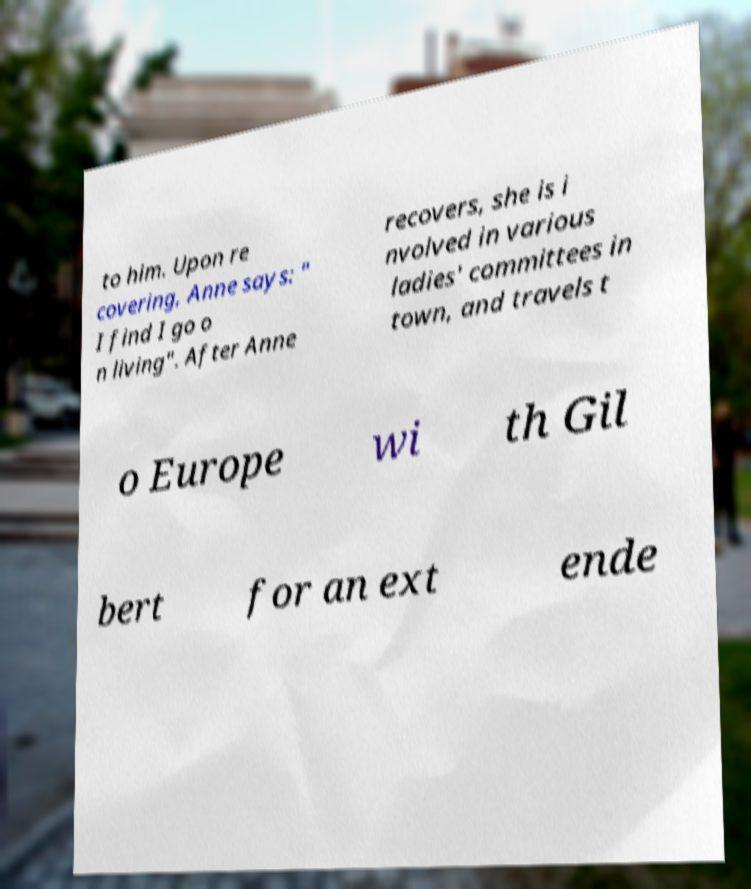Could you extract and type out the text from this image? to him. Upon re covering, Anne says: " I find I go o n living". After Anne recovers, she is i nvolved in various ladies' committees in town, and travels t o Europe wi th Gil bert for an ext ende 